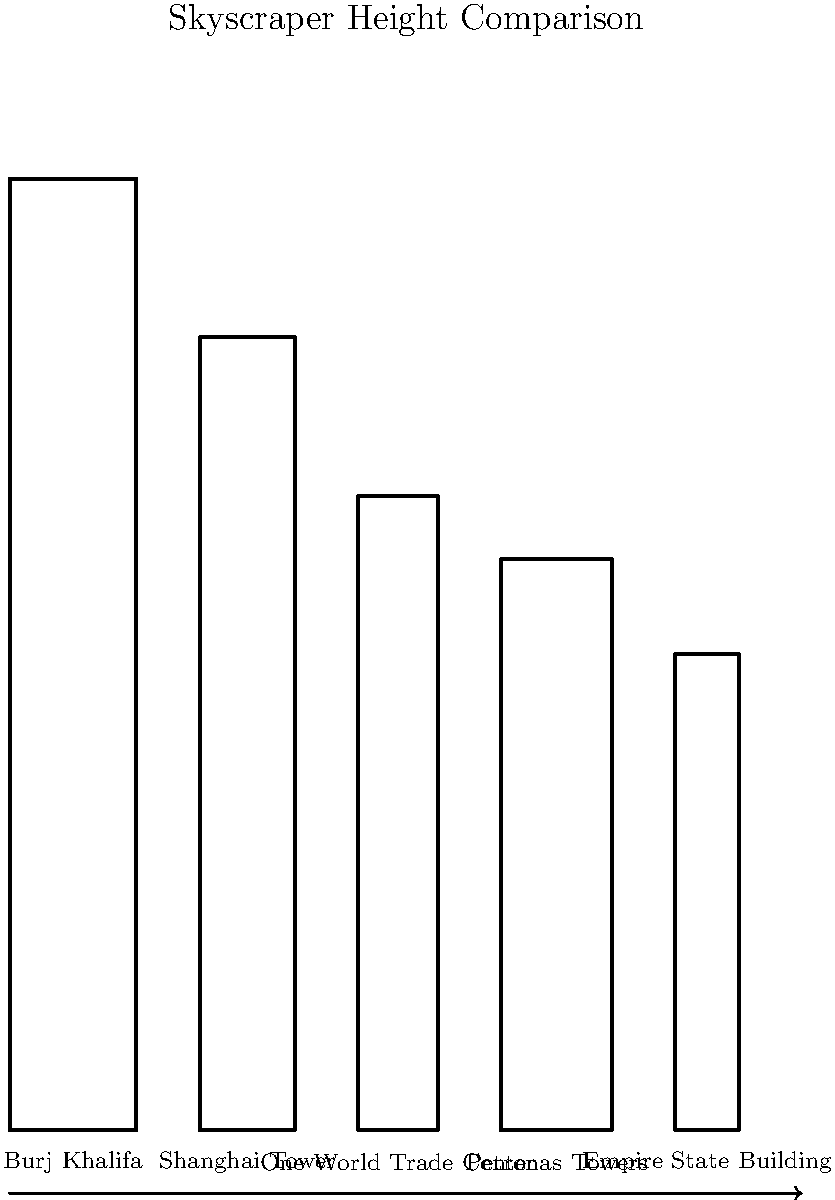Analyze the visual representation of skyscraper silhouettes. How might the varied heights and designs of these iconic structures reflect the cultural aspirations and technological advancements of their respective societies? Consider the metaphorical implications of "reaching for the sky" in your response. To answer this question, let's break down the analysis into several steps:

1. Height comparison:
   - The Burj Khalifa is notably the tallest, followed by Shanghai Tower, One World Trade Center, Petronas Towers, and the Empire State Building.
   - The varying heights represent different eras of technological capability and national ambition.

2. Cultural significance:
   - Burj Khalifa (Dubai): Symbolizes the rapid modernization and economic growth of the UAE.
   - Shanghai Tower (China): Represents China's emergence as a global economic powerhouse.
   - One World Trade Center (USA): Embodies resilience and renewal following the 9/11 attacks.
   - Petronas Towers (Malaysia): Showcases Malaysia's economic development and Islamic-inspired architecture.
   - Empire State Building (USA): An enduring symbol of American ambition from the early 20th century.

3. Metaphorical implications:
   - "Reaching for the sky" suggests aspirations for greatness, progress, and pushing boundaries.
   - Taller buildings often correlate with a society's economic strength and technological prowess.
   - The pursuit of height in architecture can be seen as a physical manifestation of human ambition.

4. Technological advancements:
   - Each successively taller building represents advancements in engineering and construction techniques.
   - The slender profiles of newer skyscrapers showcase improved materials and structural designs.

5. Societal reflections:
   - The concentration of skyscrapers often indicates urban density and the value placed on vertical space.
   - The architectural styles reflect both local cultural influences and global design trends.

6. Economic implications:
   - Skyscrapers often serve as headquarters for major corporations, reflecting economic power.
   - The cost and complexity of these structures demonstrate the financial capabilities of their builders.

In conclusion, the varied heights and designs of these skyscrapers serve as physical manifestations of cultural pride, technological achievement, and economic strength. They embody the metaphor of "reaching for the sky" by literally stretching upwards, symbolizing human ambition and the constant push to surpass previous limits.
Answer: Skyscrapers reflect cultural aspirations, technological progress, and economic power; their heights symbolize societal ambitions and the metaphorical pursuit of greatness. 